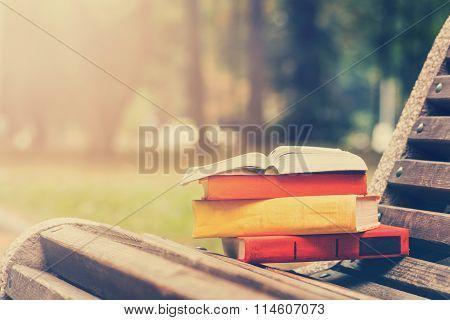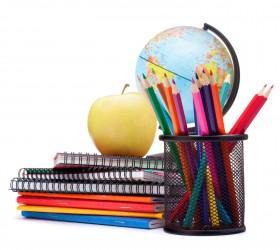The first image is the image on the left, the second image is the image on the right. Examine the images to the left and right. Is the description "there are pencils with the erasers side up" accurate? Answer yes or no. No. The first image is the image on the left, the second image is the image on the right. For the images shown, is this caption "There are no writing utensils visible in one of the pictures." true? Answer yes or no. Yes. 